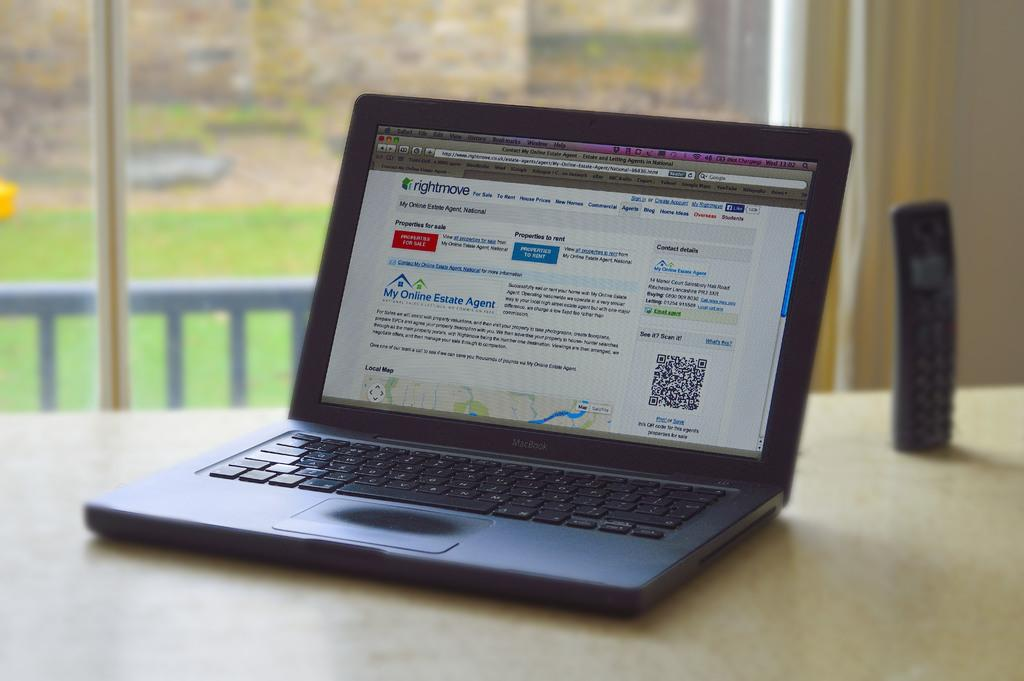<image>
Create a compact narrative representing the image presented. A laptop open with a web page with my online estate agent on the screen. 